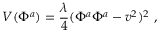<formula> <loc_0><loc_0><loc_500><loc_500>V ( \Phi ^ { a } ) = \frac { \lambda } { 4 } ( \Phi ^ { a } \Phi ^ { a } - v ^ { 2 } ) ^ { 2 } \ ,</formula> 